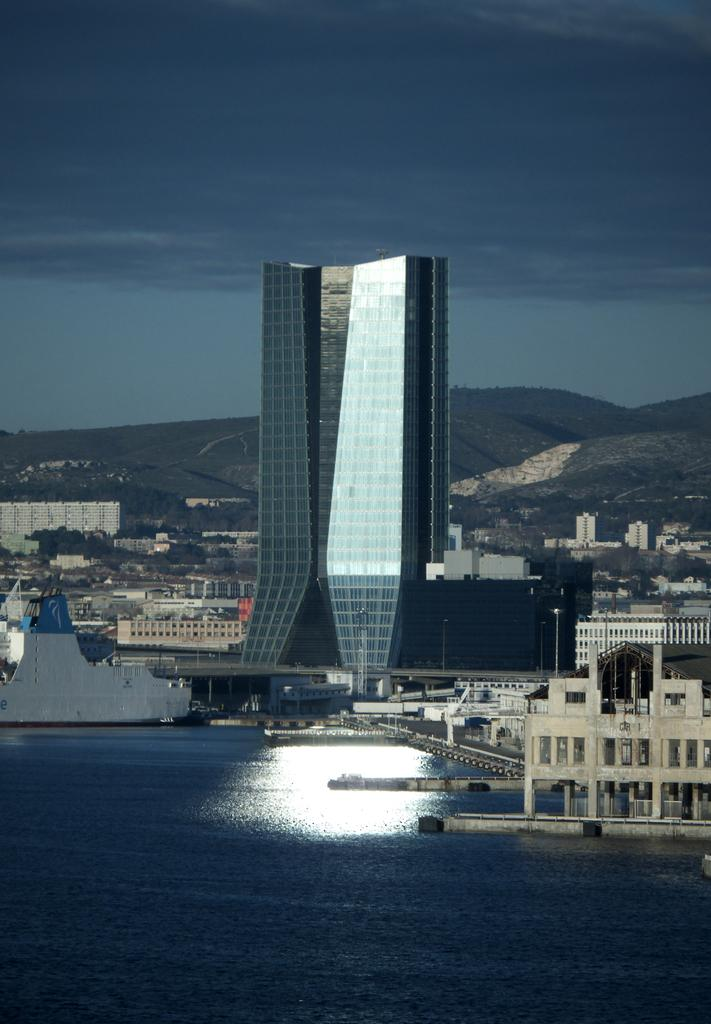What is at the bottom of the image? There is water at the bottom of the image. What can be seen on the right side of the image? There are buildings on the right side of the image. What type of vegetation is visible in the background of the image? Trees are present in the background of the image. What else can be seen in the background of the image besides trees? There are buildings and hills visible in the background of the image. What is visible at the top of the image? The sky is visible at the top of the image. How many desks are visible in the image? There are no desks present in the image. Can you see any sheep in the image? There are no sheep present in the image. 